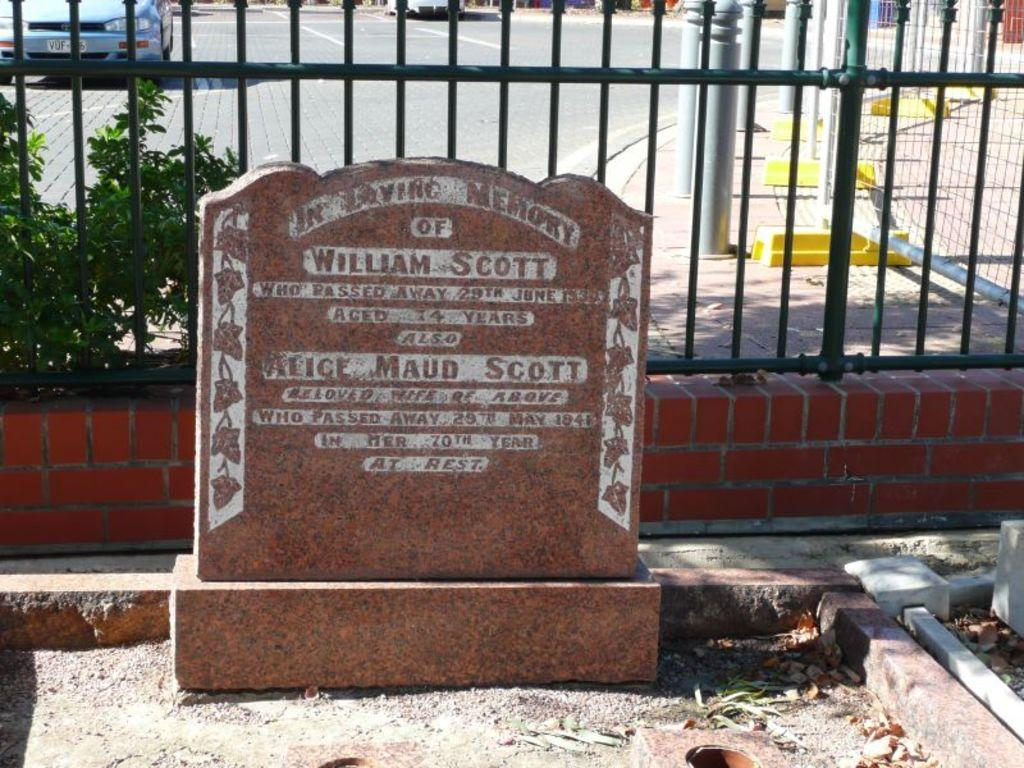What is the main object in the image? There is a brown stone in the image. What is written on the brown stone? The brown stone has "William Scott" written on it. What type of structure is present in the image? There is a black fencing grill in the image. What can be seen in the background of the image? There is a blue car and a road visible in the background of the image. Is there any blood visible on the brown stone in the image? No, there is no blood visible on the brown stone in the image. Can you see a plane flying in the sky in the image? No, there is no plane visible in the image. 